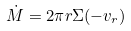<formula> <loc_0><loc_0><loc_500><loc_500>\dot { M } = 2 \pi r \Sigma ( - v _ { r } )</formula> 